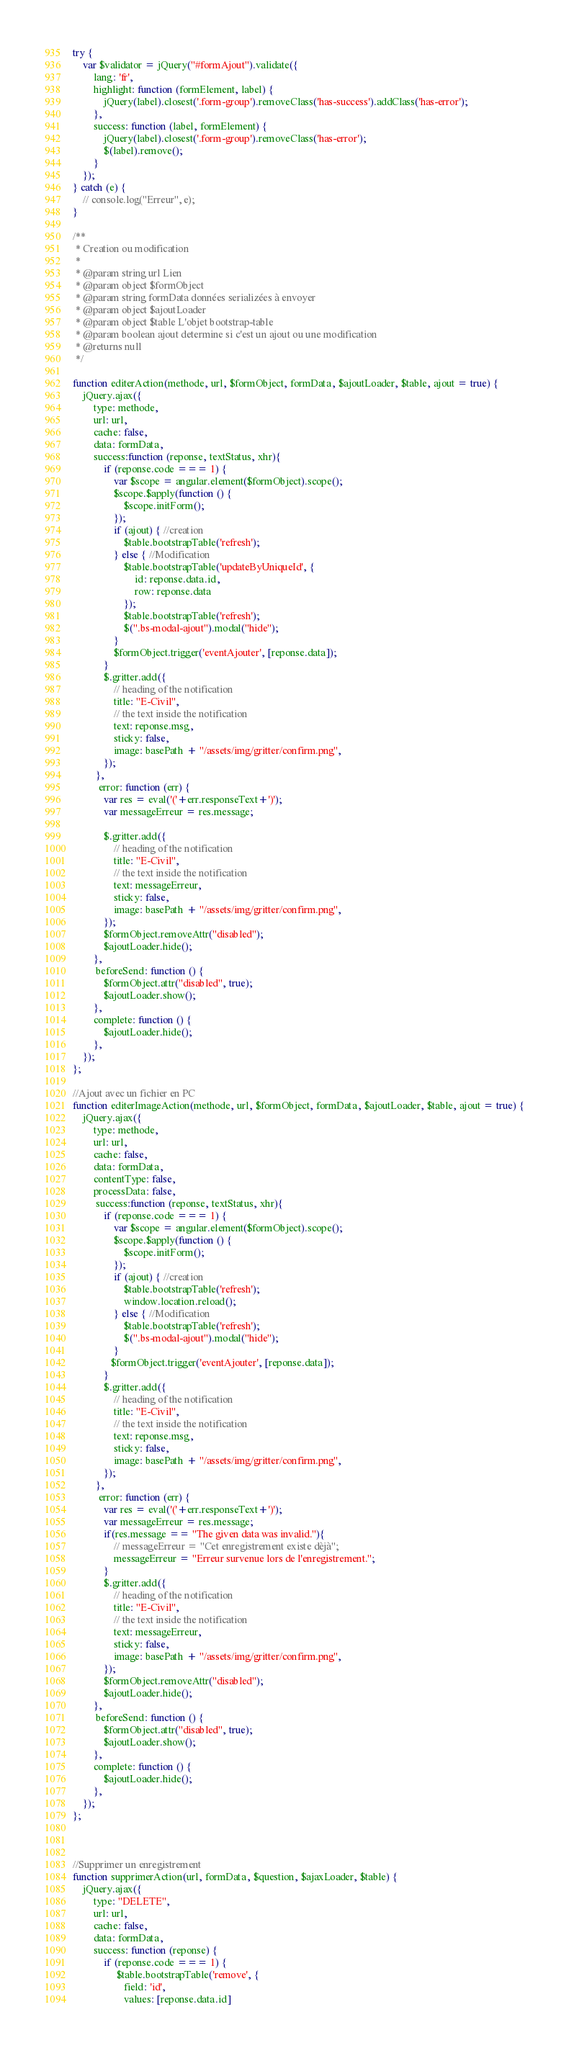<code> <loc_0><loc_0><loc_500><loc_500><_JavaScript_>try {
    var $validator = jQuery("#formAjout").validate({
        lang: 'fr',
        highlight: function (formElement, label) {
            jQuery(label).closest('.form-group').removeClass('has-success').addClass('has-error');
        },
        success: function (label, formElement) {
            jQuery(label).closest('.form-group').removeClass('has-error');
            $(label).remove();
        }
    });
} catch (e) {
    // console.log("Erreur", e);
}

/**
 * Creation ou modification
 * 
 * @param string url Lien
 * @param object $formObject
 * @param string formData données serializées à envoyer
 * @param object $ajoutLoader
 * @param object $table L'objet bootstrap-table
 * @param boolean ajout determine si c'est un ajout ou une modification
 * @returns null
 */

function editerAction(methode, url, $formObject, formData, $ajoutLoader, $table, ajout = true) {
    jQuery.ajax({
        type: methode,
        url: url,
        cache: false,
        data: formData,
        success:function (reponse, textStatus, xhr){
            if (reponse.code === 1) {
                var $scope = angular.element($formObject).scope();
                $scope.$apply(function () {
                    $scope.initForm();
                });
                if (ajout) { //creation
                    $table.bootstrapTable('refresh');
                } else { //Modification
                    $table.bootstrapTable('updateByUniqueId', {
                        id: reponse.data.id,
                        row: reponse.data
                    });
                    $table.bootstrapTable('refresh');
                    $(".bs-modal-ajout").modal("hide");
                }
                $formObject.trigger('eventAjouter', [reponse.data]);
            }
            $.gritter.add({
                // heading of the notification
                title: "E-Civil",
                // the text inside the notification
                text: reponse.msg,
                sticky: false,
                image: basePath + "/assets/img/gritter/confirm.png",
            });
         },
          error: function (err) {
            var res = eval('('+err.responseText+')');
            var messageErreur = res.message;
            
            $.gritter.add({
                // heading of the notification
                title: "E-Civil",
                // the text inside the notification
                text: messageErreur,
                sticky: false,
                image: basePath + "/assets/img/gritter/confirm.png",
            });
            $formObject.removeAttr("disabled");
            $ajoutLoader.hide();
        },
         beforeSend: function () {
            $formObject.attr("disabled", true);
            $ajoutLoader.show();
        },
        complete: function () {
            $ajoutLoader.hide();
        },
    });
};

//Ajout avec un fichier en PC
function editerImageAction(methode, url, $formObject, formData, $ajoutLoader, $table, ajout = true) {
    jQuery.ajax({
        type: methode,
        url: url,
        cache: false,
        data: formData,
        contentType: false,
        processData: false,
         success:function (reponse, textStatus, xhr){
            if (reponse.code === 1) {
                var $scope = angular.element($formObject).scope();
                $scope.$apply(function () {
                    $scope.initForm();
                });
                if (ajout) { //creation
                    $table.bootstrapTable('refresh');
                    window.location.reload();
                } else { //Modification
                    $table.bootstrapTable('refresh');
                    $(".bs-modal-ajout").modal("hide");
                }
               $formObject.trigger('eventAjouter', [reponse.data]);
            }
            $.gritter.add({
                // heading of the notification
                title: "E-Civil",
                // the text inside the notification
                text: reponse.msg,
                sticky: false,
                image: basePath + "/assets/img/gritter/confirm.png",
            });
         },
          error: function (err) {
            var res = eval('('+err.responseText+')');
            var messageErreur = res.message;
            if(res.message == "The given data was invalid."){
                // messageErreur = "Cet enregistrement existe dèjà";
                messageErreur = "Erreur survenue lors de l'enregistrement.";
            }
            $.gritter.add({
                // heading of the notification
                title: "E-Civil",
                // the text inside the notification
                text: messageErreur,
                sticky: false,
                image: basePath + "/assets/img/gritter/confirm.png",
            });
            $formObject.removeAttr("disabled");
            $ajoutLoader.hide();
        },
         beforeSend: function () {
            $formObject.attr("disabled", true);
            $ajoutLoader.show();
        },
        complete: function () {
            $ajoutLoader.hide();
        },
    });
};



//Supprimer un enregistrement
function supprimerAction(url, formData, $question, $ajaxLoader, $table) {
    jQuery.ajax({
        type: "DELETE",
        url: url,
        cache: false,
        data: formData,
        success: function (reponse) {
            if (reponse.code === 1) {
                 $table.bootstrapTable('remove', {
                    field: 'id',
                    values: [reponse.data.id]</code> 